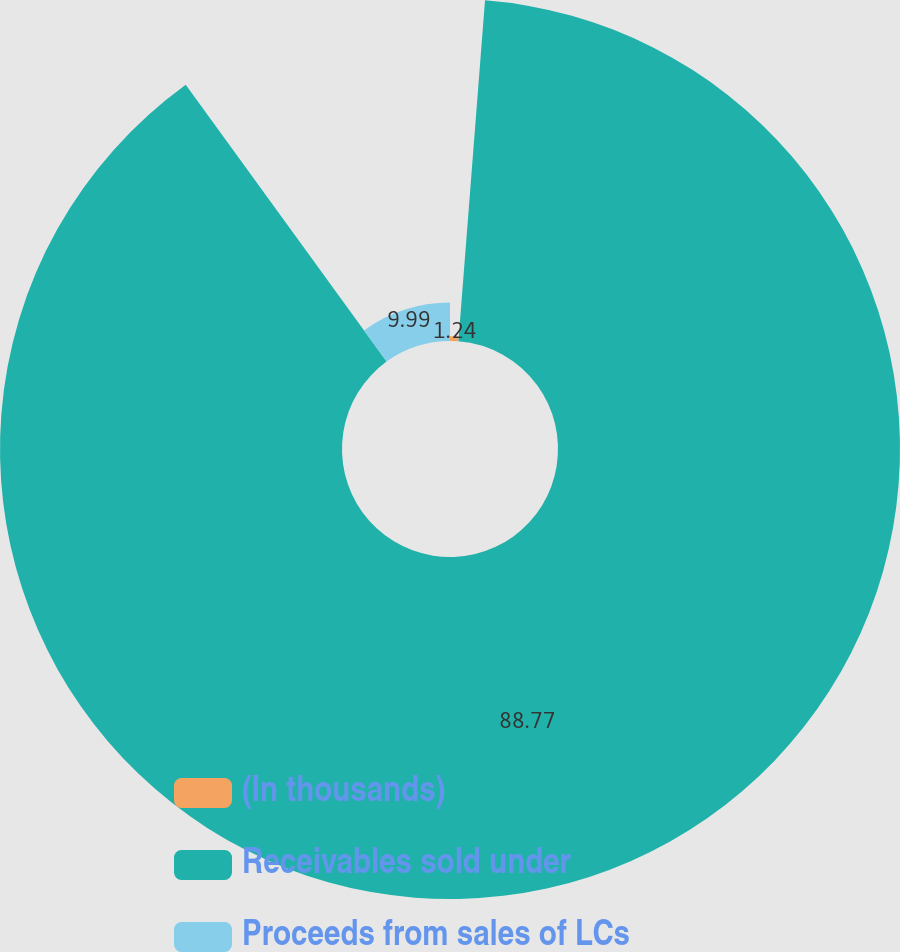<chart> <loc_0><loc_0><loc_500><loc_500><pie_chart><fcel>(In thousands)<fcel>Receivables sold under<fcel>Proceeds from sales of LCs<nl><fcel>1.24%<fcel>88.77%<fcel>9.99%<nl></chart> 